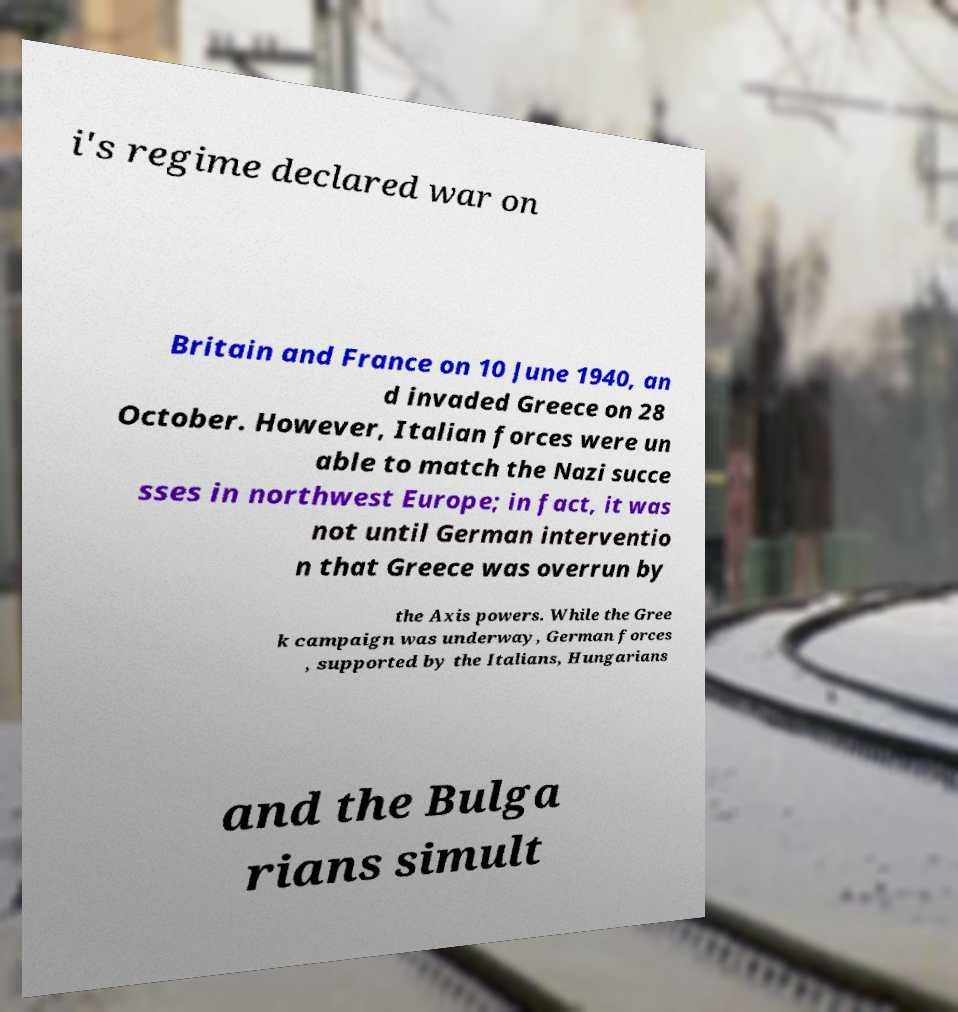There's text embedded in this image that I need extracted. Can you transcribe it verbatim? i's regime declared war on Britain and France on 10 June 1940, an d invaded Greece on 28 October. However, Italian forces were un able to match the Nazi succe sses in northwest Europe; in fact, it was not until German interventio n that Greece was overrun by the Axis powers. While the Gree k campaign was underway, German forces , supported by the Italians, Hungarians and the Bulga rians simult 